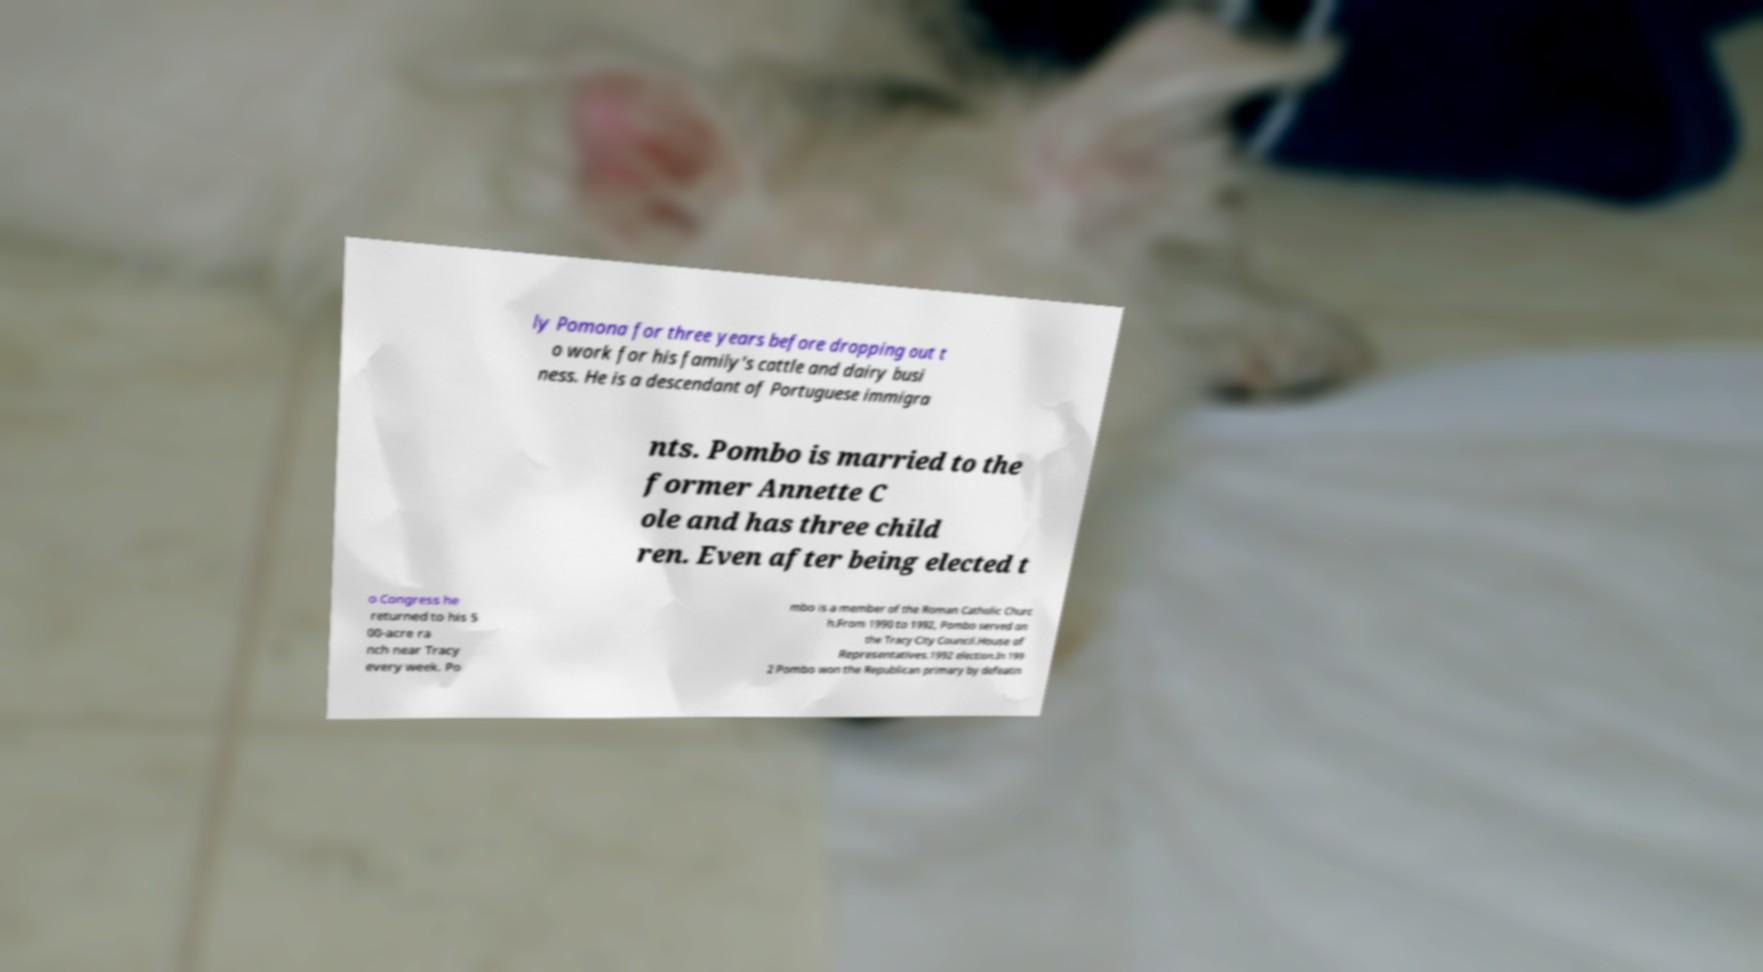Could you assist in decoding the text presented in this image and type it out clearly? ly Pomona for three years before dropping out t o work for his family's cattle and dairy busi ness. He is a descendant of Portuguese immigra nts. Pombo is married to the former Annette C ole and has three child ren. Even after being elected t o Congress he returned to his 5 00-acre ra nch near Tracy every week. Po mbo is a member of the Roman Catholic Churc h.From 1990 to 1992, Pombo served on the Tracy City Council.House of Representatives.1992 election.In 199 2 Pombo won the Republican primary by defeatin 